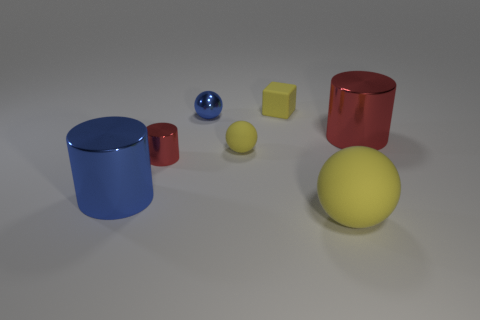What is the material of the other sphere that is the same size as the blue metallic ball?
Provide a short and direct response. Rubber. Are there any metallic spheres right of the small yellow matte ball?
Your answer should be compact. No. Are there the same number of tiny yellow rubber blocks that are in front of the big blue cylinder and large gray things?
Your response must be concise. Yes. There is a metallic thing that is the same size as the blue metallic cylinder; what shape is it?
Offer a terse response. Cylinder. What material is the blue cylinder?
Ensure brevity in your answer.  Metal. There is a object that is in front of the small cylinder and right of the big blue shiny cylinder; what color is it?
Offer a terse response. Yellow. Are there the same number of tiny rubber spheres behind the tiny blue object and spheres that are behind the large red cylinder?
Provide a succinct answer. No. The big object that is the same material as the cube is what color?
Keep it short and to the point. Yellow. Is the color of the small cube the same as the big rubber object in front of the tiny yellow sphere?
Offer a very short reply. Yes. Are there any big blue metal things right of the big cylinder on the right side of the blue shiny thing that is behind the big red object?
Your response must be concise. No. 